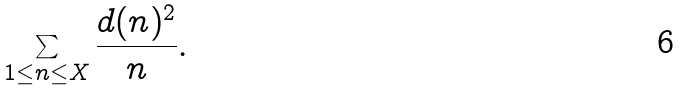<formula> <loc_0><loc_0><loc_500><loc_500>\sum _ { 1 \leq n \leq X } \frac { d ( n ) ^ { 2 } } { n } .</formula> 